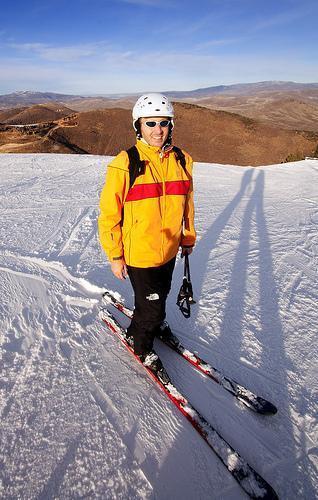How many people are pictured?
Give a very brief answer. 1. 